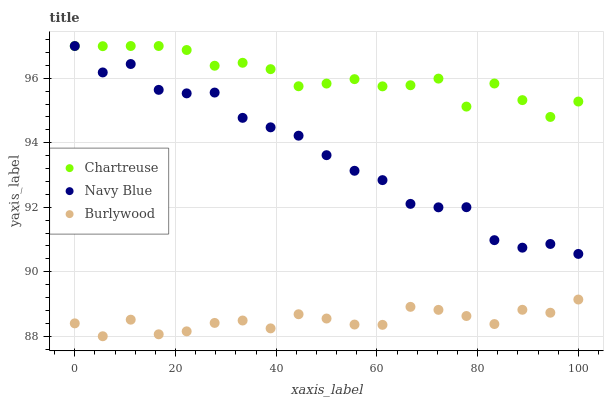Does Burlywood have the minimum area under the curve?
Answer yes or no. Yes. Does Chartreuse have the maximum area under the curve?
Answer yes or no. Yes. Does Navy Blue have the minimum area under the curve?
Answer yes or no. No. Does Navy Blue have the maximum area under the curve?
Answer yes or no. No. Is Burlywood the smoothest?
Answer yes or no. Yes. Is Navy Blue the roughest?
Answer yes or no. Yes. Is Chartreuse the smoothest?
Answer yes or no. No. Is Chartreuse the roughest?
Answer yes or no. No. Does Burlywood have the lowest value?
Answer yes or no. Yes. Does Navy Blue have the lowest value?
Answer yes or no. No. Does Chartreuse have the highest value?
Answer yes or no. Yes. Is Burlywood less than Navy Blue?
Answer yes or no. Yes. Is Chartreuse greater than Burlywood?
Answer yes or no. Yes. Does Chartreuse intersect Navy Blue?
Answer yes or no. Yes. Is Chartreuse less than Navy Blue?
Answer yes or no. No. Is Chartreuse greater than Navy Blue?
Answer yes or no. No. Does Burlywood intersect Navy Blue?
Answer yes or no. No. 